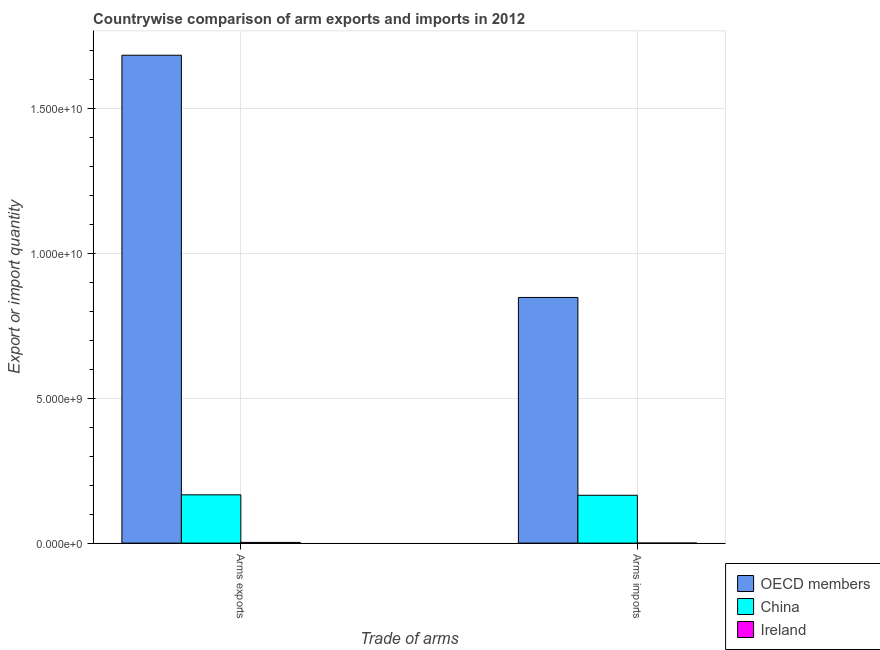Are the number of bars per tick equal to the number of legend labels?
Provide a short and direct response. Yes. What is the label of the 1st group of bars from the left?
Your response must be concise. Arms exports. What is the arms exports in Ireland?
Offer a very short reply. 2.50e+07. Across all countries, what is the maximum arms imports?
Your answer should be very brief. 8.48e+09. Across all countries, what is the minimum arms exports?
Offer a terse response. 2.50e+07. In which country was the arms imports minimum?
Your answer should be very brief. Ireland. What is the total arms exports in the graph?
Provide a short and direct response. 1.85e+1. What is the difference between the arms exports in OECD members and that in China?
Provide a short and direct response. 1.52e+1. What is the difference between the arms exports in Ireland and the arms imports in OECD members?
Your response must be concise. -8.45e+09. What is the average arms exports per country?
Your response must be concise. 6.18e+09. What is the difference between the arms imports and arms exports in Ireland?
Give a very brief answer. -2.40e+07. What is the ratio of the arms imports in Ireland to that in China?
Ensure brevity in your answer.  0. Is the arms exports in OECD members less than that in China?
Give a very brief answer. No. In how many countries, is the arms exports greater than the average arms exports taken over all countries?
Your answer should be very brief. 1. What does the 2nd bar from the right in Arms imports represents?
Your answer should be compact. China. What is the difference between two consecutive major ticks on the Y-axis?
Offer a very short reply. 5.00e+09. Are the values on the major ticks of Y-axis written in scientific E-notation?
Provide a succinct answer. Yes. Does the graph contain grids?
Ensure brevity in your answer.  Yes. Where does the legend appear in the graph?
Ensure brevity in your answer.  Bottom right. How are the legend labels stacked?
Give a very brief answer. Vertical. What is the title of the graph?
Give a very brief answer. Countrywise comparison of arm exports and imports in 2012. Does "Aruba" appear as one of the legend labels in the graph?
Make the answer very short. No. What is the label or title of the X-axis?
Keep it short and to the point. Trade of arms. What is the label or title of the Y-axis?
Give a very brief answer. Export or import quantity. What is the Export or import quantity of OECD members in Arms exports?
Your answer should be very brief. 1.68e+1. What is the Export or import quantity of China in Arms exports?
Your response must be concise. 1.67e+09. What is the Export or import quantity in Ireland in Arms exports?
Your answer should be compact. 2.50e+07. What is the Export or import quantity of OECD members in Arms imports?
Offer a very short reply. 8.48e+09. What is the Export or import quantity in China in Arms imports?
Provide a succinct answer. 1.65e+09. Across all Trade of arms, what is the maximum Export or import quantity in OECD members?
Make the answer very short. 1.68e+1. Across all Trade of arms, what is the maximum Export or import quantity in China?
Keep it short and to the point. 1.67e+09. Across all Trade of arms, what is the maximum Export or import quantity in Ireland?
Provide a succinct answer. 2.50e+07. Across all Trade of arms, what is the minimum Export or import quantity in OECD members?
Give a very brief answer. 8.48e+09. Across all Trade of arms, what is the minimum Export or import quantity of China?
Keep it short and to the point. 1.65e+09. Across all Trade of arms, what is the minimum Export or import quantity in Ireland?
Keep it short and to the point. 1.00e+06. What is the total Export or import quantity in OECD members in the graph?
Keep it short and to the point. 2.53e+1. What is the total Export or import quantity in China in the graph?
Provide a short and direct response. 3.32e+09. What is the total Export or import quantity in Ireland in the graph?
Ensure brevity in your answer.  2.60e+07. What is the difference between the Export or import quantity in OECD members in Arms exports and that in Arms imports?
Keep it short and to the point. 8.36e+09. What is the difference between the Export or import quantity in China in Arms exports and that in Arms imports?
Ensure brevity in your answer.  1.50e+07. What is the difference between the Export or import quantity in Ireland in Arms exports and that in Arms imports?
Provide a short and direct response. 2.40e+07. What is the difference between the Export or import quantity in OECD members in Arms exports and the Export or import quantity in China in Arms imports?
Offer a terse response. 1.52e+1. What is the difference between the Export or import quantity of OECD members in Arms exports and the Export or import quantity of Ireland in Arms imports?
Your answer should be compact. 1.68e+1. What is the difference between the Export or import quantity of China in Arms exports and the Export or import quantity of Ireland in Arms imports?
Offer a terse response. 1.66e+09. What is the average Export or import quantity in OECD members per Trade of arms?
Provide a short and direct response. 1.27e+1. What is the average Export or import quantity in China per Trade of arms?
Give a very brief answer. 1.66e+09. What is the average Export or import quantity of Ireland per Trade of arms?
Provide a succinct answer. 1.30e+07. What is the difference between the Export or import quantity in OECD members and Export or import quantity in China in Arms exports?
Offer a very short reply. 1.52e+1. What is the difference between the Export or import quantity of OECD members and Export or import quantity of Ireland in Arms exports?
Provide a succinct answer. 1.68e+1. What is the difference between the Export or import quantity of China and Export or import quantity of Ireland in Arms exports?
Your answer should be very brief. 1.64e+09. What is the difference between the Export or import quantity of OECD members and Export or import quantity of China in Arms imports?
Keep it short and to the point. 6.83e+09. What is the difference between the Export or import quantity in OECD members and Export or import quantity in Ireland in Arms imports?
Provide a short and direct response. 8.48e+09. What is the difference between the Export or import quantity in China and Export or import quantity in Ireland in Arms imports?
Your answer should be compact. 1.65e+09. What is the ratio of the Export or import quantity of OECD members in Arms exports to that in Arms imports?
Your answer should be compact. 1.99. What is the ratio of the Export or import quantity in China in Arms exports to that in Arms imports?
Keep it short and to the point. 1.01. What is the ratio of the Export or import quantity of Ireland in Arms exports to that in Arms imports?
Your answer should be very brief. 25. What is the difference between the highest and the second highest Export or import quantity of OECD members?
Offer a terse response. 8.36e+09. What is the difference between the highest and the second highest Export or import quantity of China?
Provide a short and direct response. 1.50e+07. What is the difference between the highest and the second highest Export or import quantity in Ireland?
Keep it short and to the point. 2.40e+07. What is the difference between the highest and the lowest Export or import quantity in OECD members?
Make the answer very short. 8.36e+09. What is the difference between the highest and the lowest Export or import quantity of China?
Provide a short and direct response. 1.50e+07. What is the difference between the highest and the lowest Export or import quantity in Ireland?
Ensure brevity in your answer.  2.40e+07. 